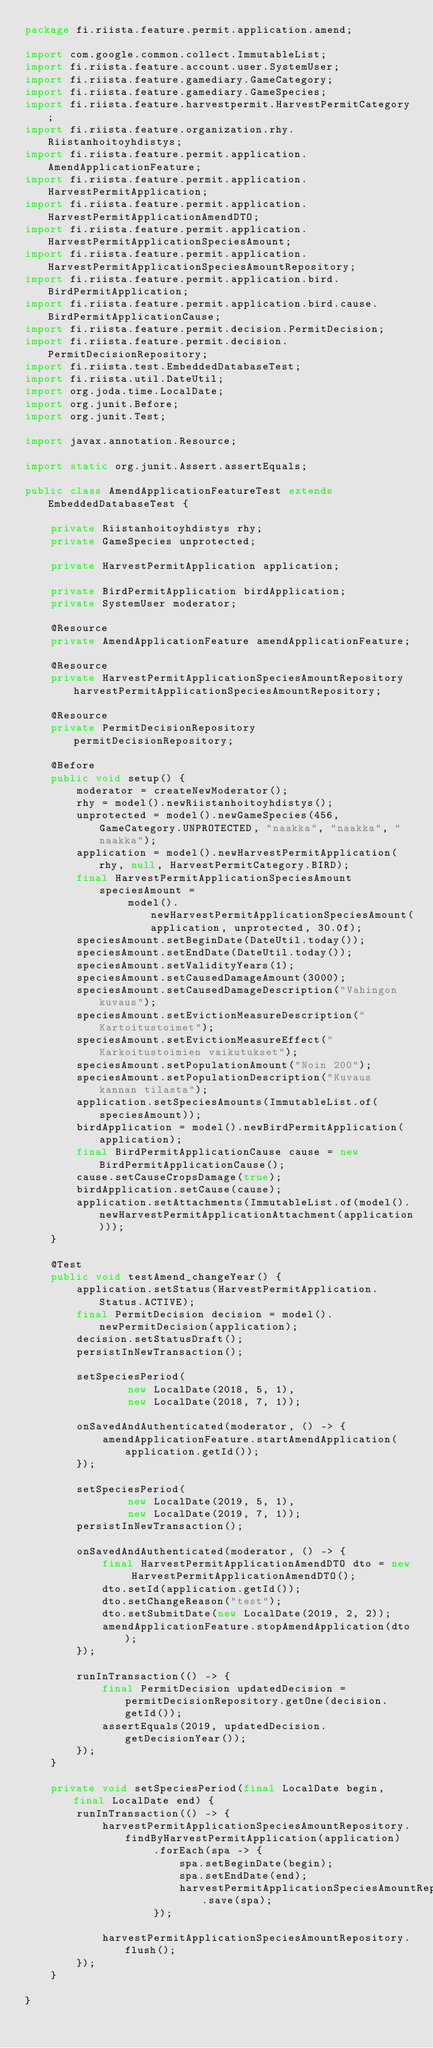Convert code to text. <code><loc_0><loc_0><loc_500><loc_500><_Java_>package fi.riista.feature.permit.application.amend;

import com.google.common.collect.ImmutableList;
import fi.riista.feature.account.user.SystemUser;
import fi.riista.feature.gamediary.GameCategory;
import fi.riista.feature.gamediary.GameSpecies;
import fi.riista.feature.harvestpermit.HarvestPermitCategory;
import fi.riista.feature.organization.rhy.Riistanhoitoyhdistys;
import fi.riista.feature.permit.application.AmendApplicationFeature;
import fi.riista.feature.permit.application.HarvestPermitApplication;
import fi.riista.feature.permit.application.HarvestPermitApplicationAmendDTO;
import fi.riista.feature.permit.application.HarvestPermitApplicationSpeciesAmount;
import fi.riista.feature.permit.application.HarvestPermitApplicationSpeciesAmountRepository;
import fi.riista.feature.permit.application.bird.BirdPermitApplication;
import fi.riista.feature.permit.application.bird.cause.BirdPermitApplicationCause;
import fi.riista.feature.permit.decision.PermitDecision;
import fi.riista.feature.permit.decision.PermitDecisionRepository;
import fi.riista.test.EmbeddedDatabaseTest;
import fi.riista.util.DateUtil;
import org.joda.time.LocalDate;
import org.junit.Before;
import org.junit.Test;

import javax.annotation.Resource;

import static org.junit.Assert.assertEquals;

public class AmendApplicationFeatureTest extends EmbeddedDatabaseTest {

    private Riistanhoitoyhdistys rhy;
    private GameSpecies unprotected;

    private HarvestPermitApplication application;

    private BirdPermitApplication birdApplication;
    private SystemUser moderator;

    @Resource
    private AmendApplicationFeature amendApplicationFeature;

    @Resource
    private HarvestPermitApplicationSpeciesAmountRepository harvestPermitApplicationSpeciesAmountRepository;

    @Resource
    private PermitDecisionRepository permitDecisionRepository;

    @Before
    public void setup() {
        moderator = createNewModerator();
        rhy = model().newRiistanhoitoyhdistys();
        unprotected = model().newGameSpecies(456, GameCategory.UNPROTECTED, "naakka", "naakka", "naakka");
        application = model().newHarvestPermitApplication(rhy, null, HarvestPermitCategory.BIRD);
        final HarvestPermitApplicationSpeciesAmount speciesAmount =
                model().newHarvestPermitApplicationSpeciesAmount(application, unprotected, 30.0f);
        speciesAmount.setBeginDate(DateUtil.today());
        speciesAmount.setEndDate(DateUtil.today());
        speciesAmount.setValidityYears(1);
        speciesAmount.setCausedDamageAmount(3000);
        speciesAmount.setCausedDamageDescription("Vahingon kuvaus");
        speciesAmount.setEvictionMeasureDescription("Kartoitustoimet");
        speciesAmount.setEvictionMeasureEffect("Karkoitustoimien vaikutukset");
        speciesAmount.setPopulationAmount("Noin 200");
        speciesAmount.setPopulationDescription("Kuvaus kannan tilasta");
        application.setSpeciesAmounts(ImmutableList.of(speciesAmount));
        birdApplication = model().newBirdPermitApplication(application);
        final BirdPermitApplicationCause cause = new BirdPermitApplicationCause();
        cause.setCauseCropsDamage(true);
        birdApplication.setCause(cause);
        application.setAttachments(ImmutableList.of(model().newHarvestPermitApplicationAttachment(application)));
    }

    @Test
    public void testAmend_changeYear() {
        application.setStatus(HarvestPermitApplication.Status.ACTIVE);
        final PermitDecision decision = model().newPermitDecision(application);
        decision.setStatusDraft();
        persistInNewTransaction();

        setSpeciesPeriod(
                new LocalDate(2018, 5, 1),
                new LocalDate(2018, 7, 1));

        onSavedAndAuthenticated(moderator, () -> {
            amendApplicationFeature.startAmendApplication(application.getId());
        });

        setSpeciesPeriod(
                new LocalDate(2019, 5, 1),
                new LocalDate(2019, 7, 1));
        persistInNewTransaction();

        onSavedAndAuthenticated(moderator, () -> {
            final HarvestPermitApplicationAmendDTO dto = new HarvestPermitApplicationAmendDTO();
            dto.setId(application.getId());
            dto.setChangeReason("test");
            dto.setSubmitDate(new LocalDate(2019, 2, 2));
            amendApplicationFeature.stopAmendApplication(dto);
        });

        runInTransaction(() -> {
            final PermitDecision updatedDecision = permitDecisionRepository.getOne(decision.getId());
            assertEquals(2019, updatedDecision.getDecisionYear());
        });
    }

    private void setSpeciesPeriod(final LocalDate begin, final LocalDate end) {
        runInTransaction(() -> {
            harvestPermitApplicationSpeciesAmountRepository.findByHarvestPermitApplication(application)
                    .forEach(spa -> {
                        spa.setBeginDate(begin);
                        spa.setEndDate(end);
                        harvestPermitApplicationSpeciesAmountRepository.save(spa);
                    });

            harvestPermitApplicationSpeciesAmountRepository.flush();
        });
    }

}
</code> 